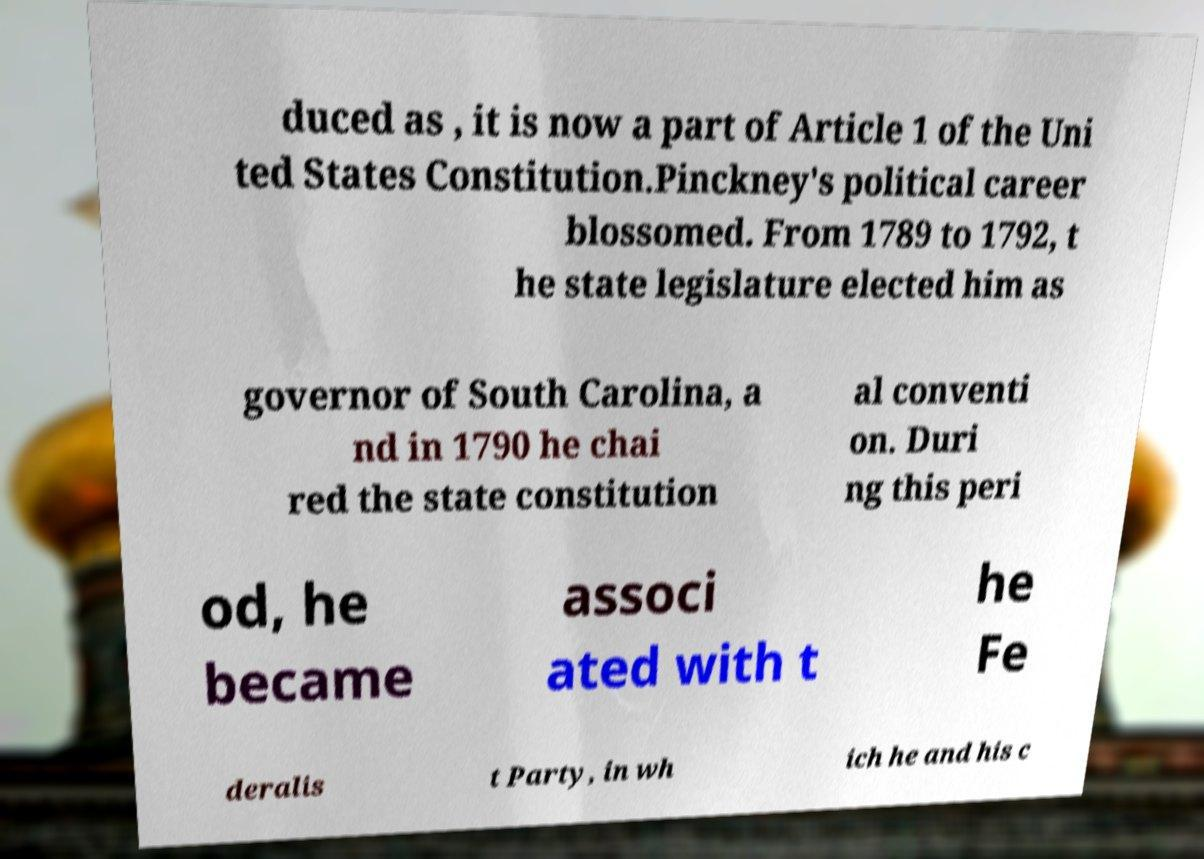Please read and relay the text visible in this image. What does it say? duced as , it is now a part of Article 1 of the Uni ted States Constitution.Pinckney's political career blossomed. From 1789 to 1792, t he state legislature elected him as governor of South Carolina, a nd in 1790 he chai red the state constitution al conventi on. Duri ng this peri od, he became associ ated with t he Fe deralis t Party, in wh ich he and his c 